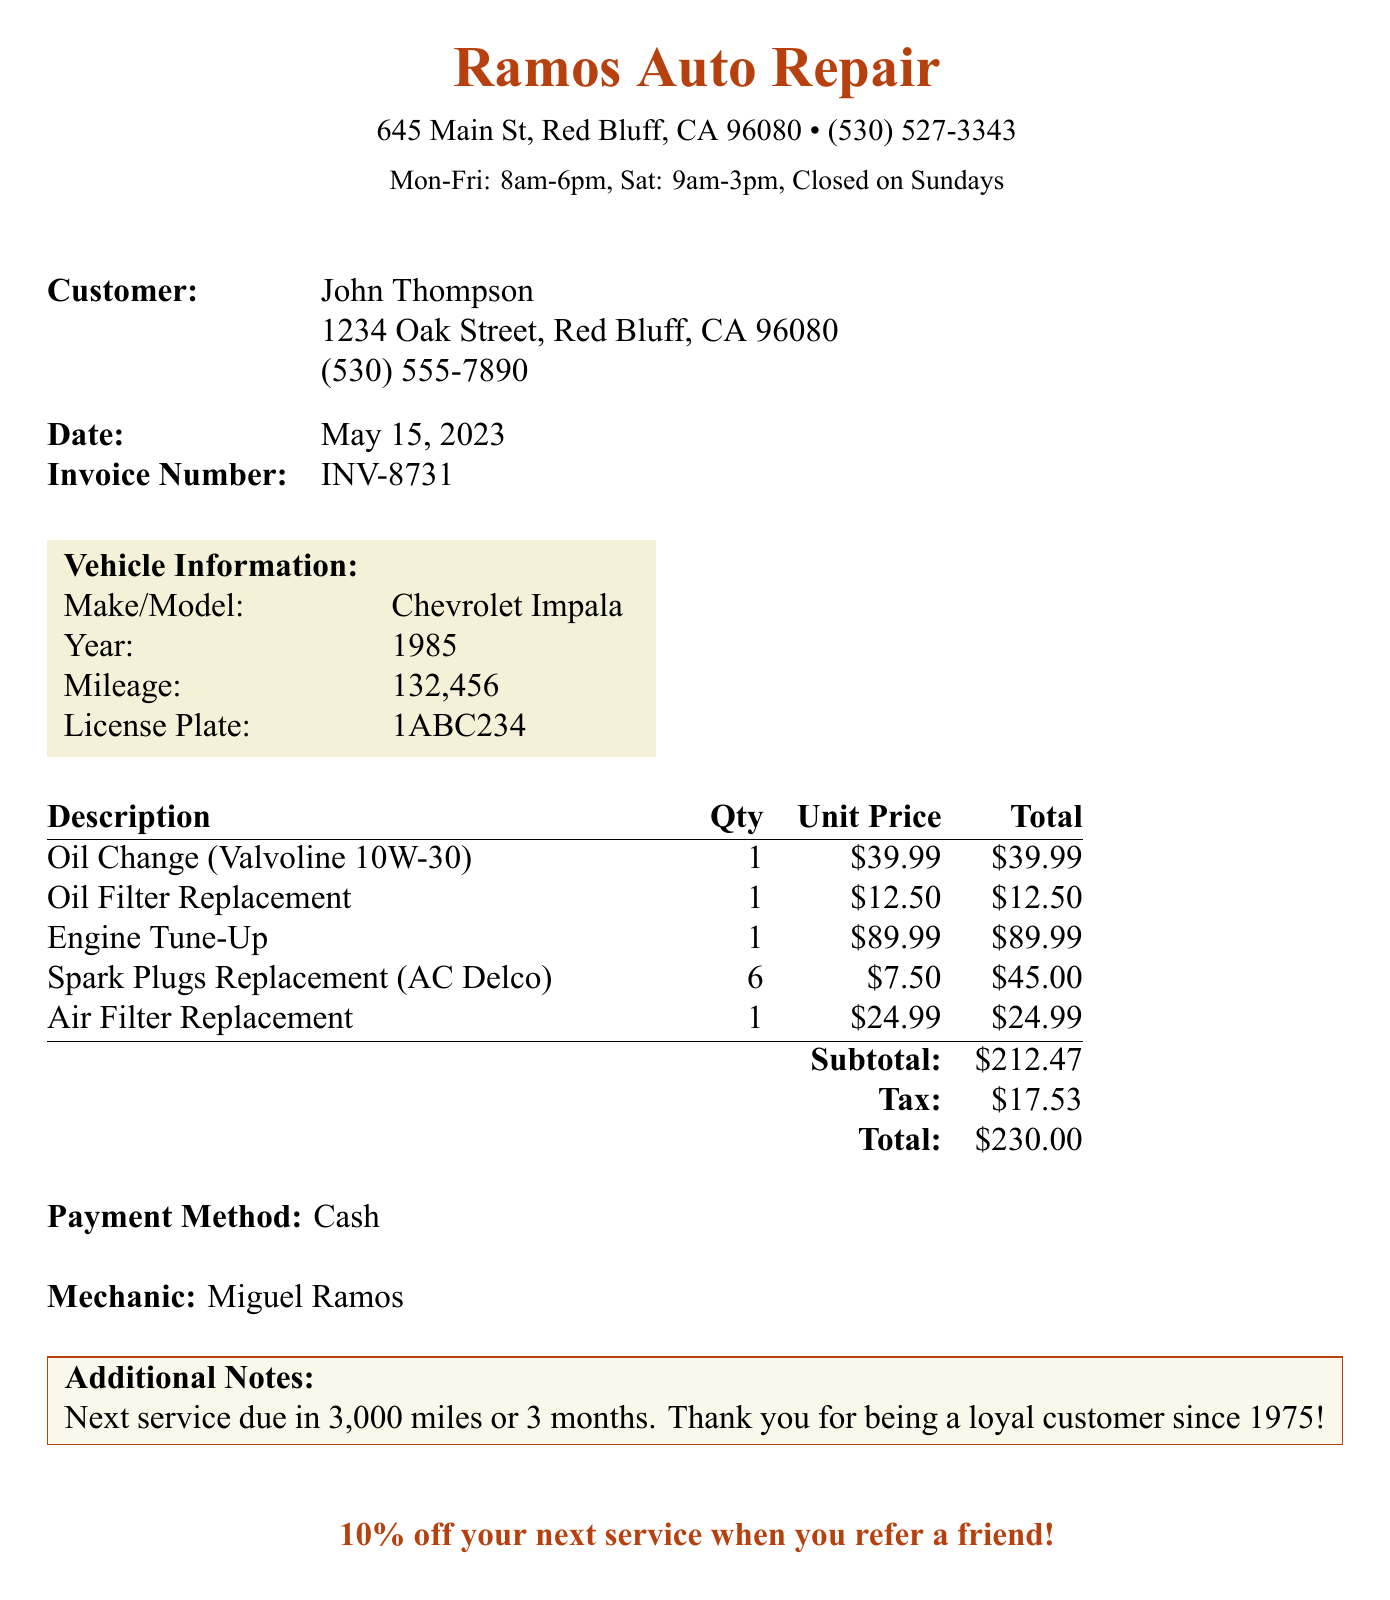What is the business name? The business name is prominently displayed at the top of the document.
Answer: Ramos Auto Repair Who is the customer? The customer's name is listed under the customer information section.
Answer: John Thompson What is the invoice number? The invoice number is included in the document for reference.
Answer: INV-8731 What is the total amount charged? The total amount charged can be found in the summary section of the receipt.
Answer: $230.00 When is the next service due? The next service due is mentioned in the additional notes section of the document.
Answer: 3,000 miles or 3 months How many spark plugs were replaced? The quantity of spark plugs replaced is noted in the list of services provided.
Answer: 6 What payment method was used? The payment method is specified towards the end of the receipt.
Answer: Cash Who performed the service? The mechanic's name is provided at the bottom of the document.
Answer: Miguel Ramos What is the subtotal before tax? The subtotal is listed right before tax in the summary table.
Answer: $212.47 